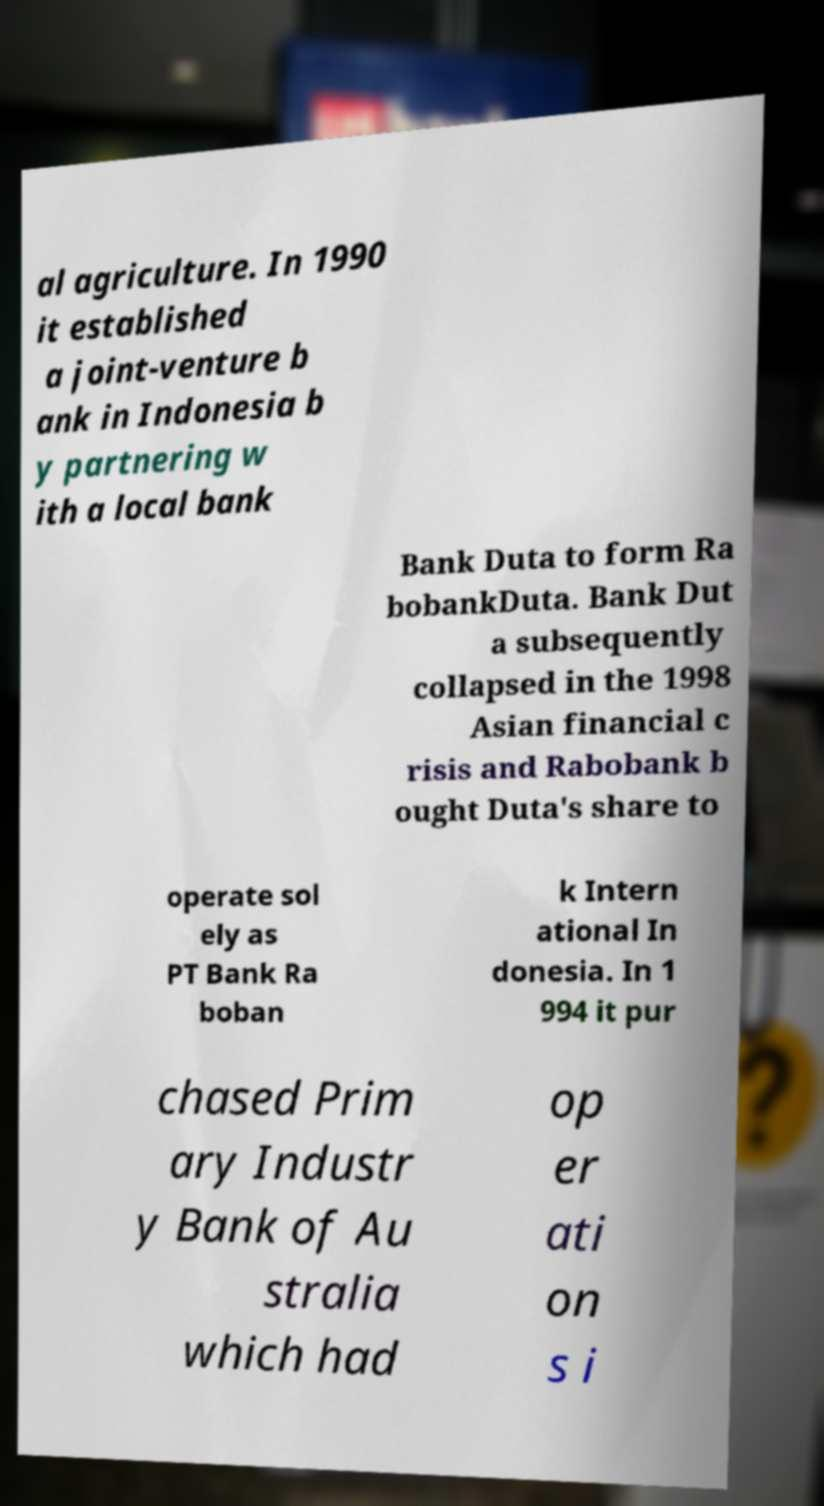Can you accurately transcribe the text from the provided image for me? al agriculture. In 1990 it established a joint-venture b ank in Indonesia b y partnering w ith a local bank Bank Duta to form Ra bobankDuta. Bank Dut a subsequently collapsed in the 1998 Asian financial c risis and Rabobank b ought Duta's share to operate sol ely as PT Bank Ra boban k Intern ational In donesia. In 1 994 it pur chased Prim ary Industr y Bank of Au stralia which had op er ati on s i 